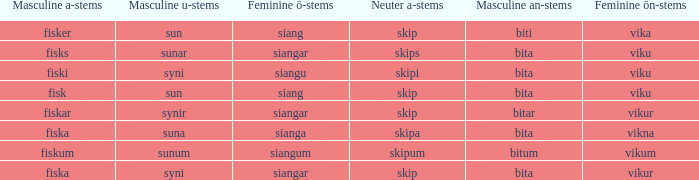What ending does siangu get for ön? Viku. Could you parse the entire table as a dict? {'header': ['Masculine a-stems', 'Masculine u-stems', 'Feminine ō-stems', 'Neuter a-stems', 'Masculine an-stems', 'Feminine ōn-stems'], 'rows': [['fisker', 'sun', 'siang', 'skip', 'biti', 'vika'], ['fisks', 'sunar', 'siangar', 'skips', 'bita', 'viku'], ['fiski', 'syni', 'siangu', 'skipi', 'bita', 'viku'], ['fisk', 'sun', 'siang', 'skip', 'bita', 'viku'], ['fiskar', 'synir', 'siangar', 'skip', 'bitar', 'vikur'], ['fiska', 'suna', 'sianga', 'skipa', 'bita', 'vikna'], ['fiskum', 'sunum', 'siangum', 'skipum', 'bitum', 'vikum'], ['fiska', 'syni', 'siangar', 'skip', 'bita', 'vikur']]} 